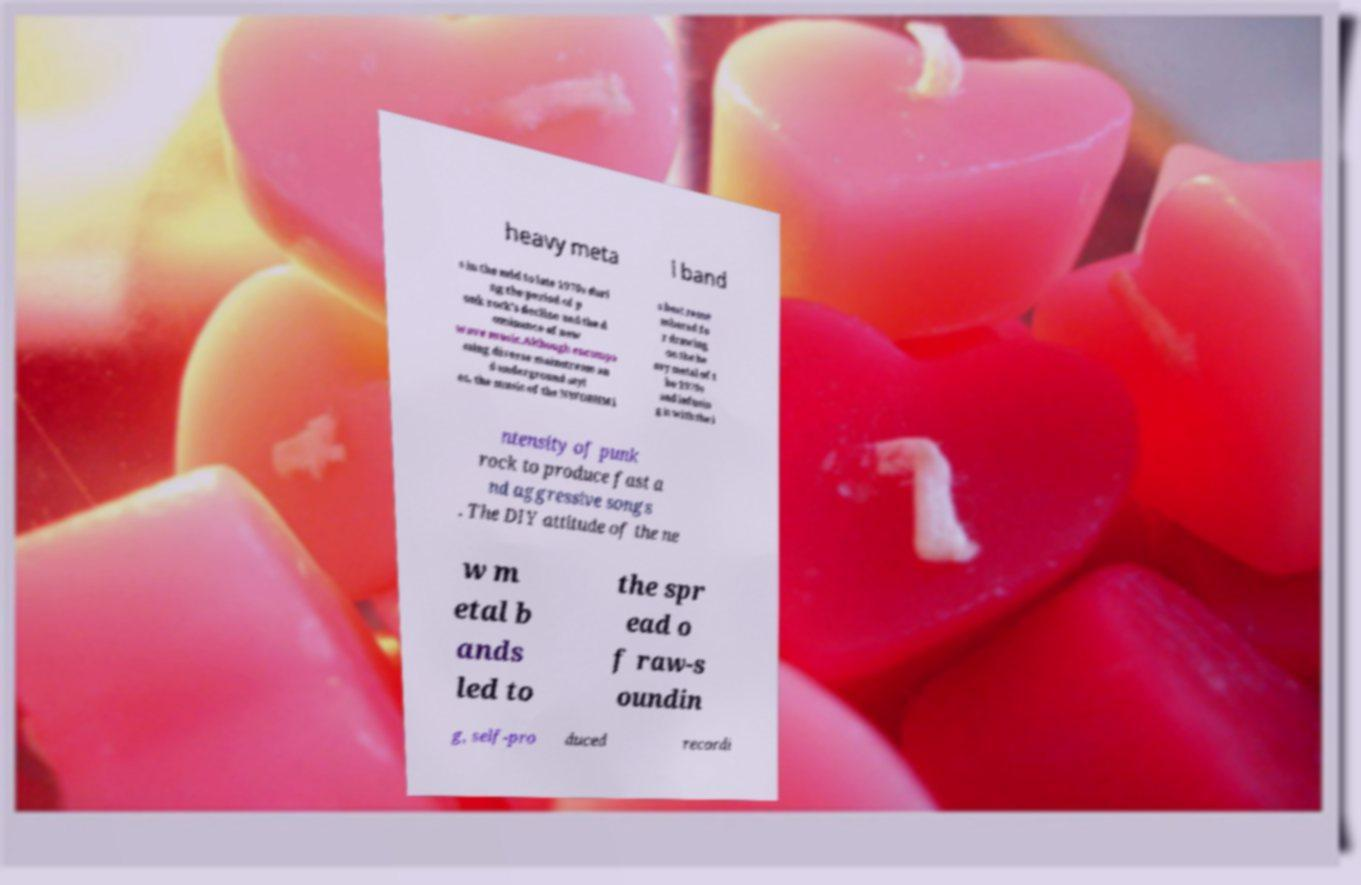What messages or text are displayed in this image? I need them in a readable, typed format. heavy meta l band s in the mid to late 1970s duri ng the period of p unk rock's decline and the d ominance of new wave music.Although encompa ssing diverse mainstream an d underground styl es, the music of the NWOBHM i s best reme mbered fo r drawing on the he avy metal of t he 1970s and infusin g it with the i ntensity of punk rock to produce fast a nd aggressive songs . The DIY attitude of the ne w m etal b ands led to the spr ead o f raw-s oundin g, self-pro duced recordi 